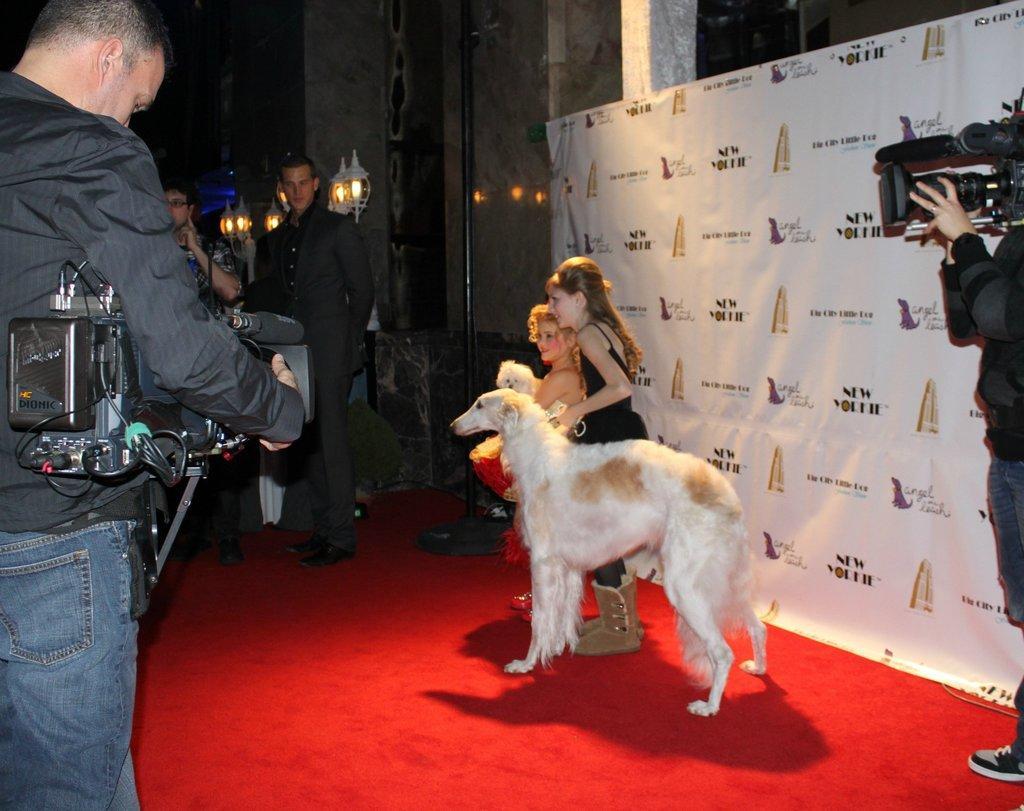How would you summarize this image in a sentence or two? This person is standing and holding a camera. Beside this girl there is a animal. This is banner. Beside this banner a person is holding a camera. Far this person wore a suit. On wall there are lights. 